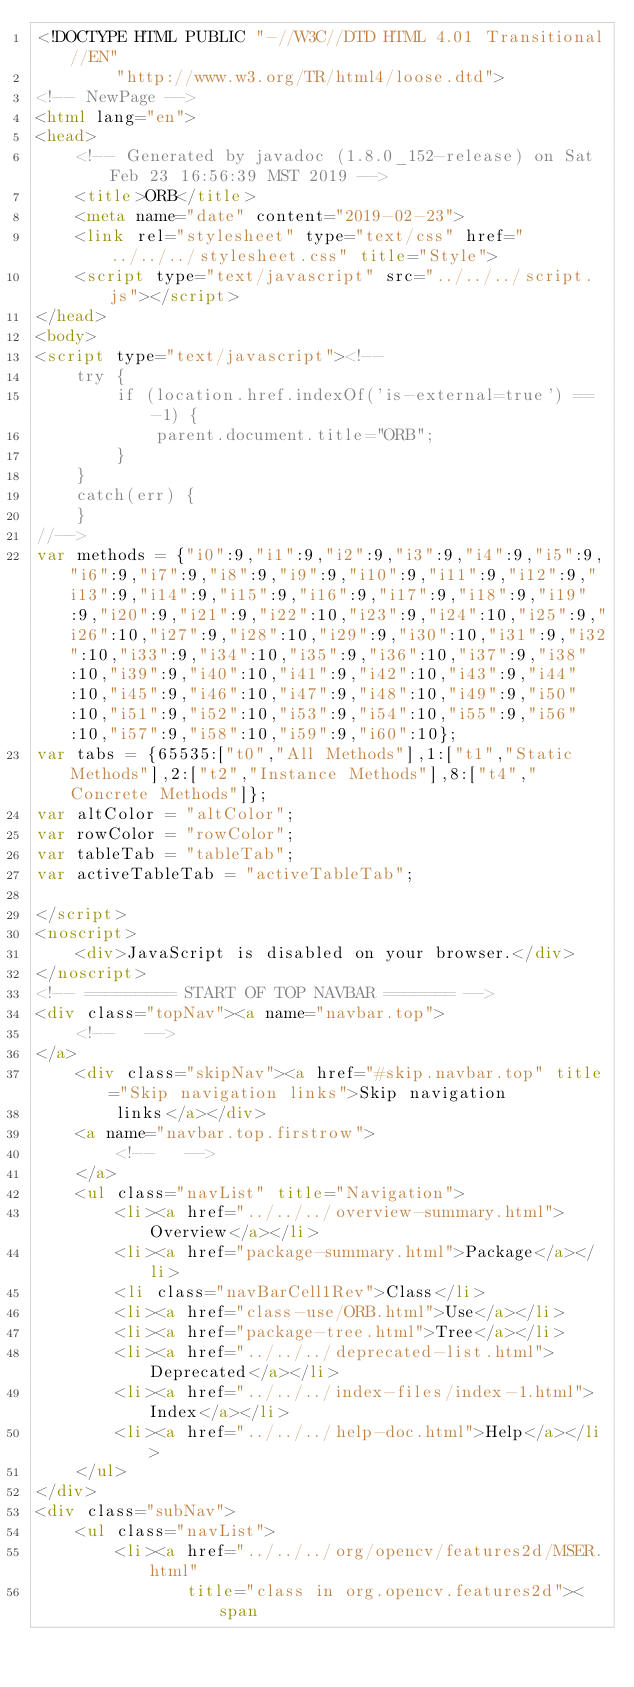Convert code to text. <code><loc_0><loc_0><loc_500><loc_500><_HTML_><!DOCTYPE HTML PUBLIC "-//W3C//DTD HTML 4.01 Transitional//EN"
        "http://www.w3.org/TR/html4/loose.dtd">
<!-- NewPage -->
<html lang="en">
<head>
    <!-- Generated by javadoc (1.8.0_152-release) on Sat Feb 23 16:56:39 MST 2019 -->
    <title>ORB</title>
    <meta name="date" content="2019-02-23">
    <link rel="stylesheet" type="text/css" href="../../../stylesheet.css" title="Style">
    <script type="text/javascript" src="../../../script.js"></script>
</head>
<body>
<script type="text/javascript"><!--
    try {
        if (location.href.indexOf('is-external=true') == -1) {
            parent.document.title="ORB";
        }
    }
    catch(err) {
    }
//-->
var methods = {"i0":9,"i1":9,"i2":9,"i3":9,"i4":9,"i5":9,"i6":9,"i7":9,"i8":9,"i9":9,"i10":9,"i11":9,"i12":9,"i13":9,"i14":9,"i15":9,"i16":9,"i17":9,"i18":9,"i19":9,"i20":9,"i21":9,"i22":10,"i23":9,"i24":10,"i25":9,"i26":10,"i27":9,"i28":10,"i29":9,"i30":10,"i31":9,"i32":10,"i33":9,"i34":10,"i35":9,"i36":10,"i37":9,"i38":10,"i39":9,"i40":10,"i41":9,"i42":10,"i43":9,"i44":10,"i45":9,"i46":10,"i47":9,"i48":10,"i49":9,"i50":10,"i51":9,"i52":10,"i53":9,"i54":10,"i55":9,"i56":10,"i57":9,"i58":10,"i59":9,"i60":10};
var tabs = {65535:["t0","All Methods"],1:["t1","Static Methods"],2:["t2","Instance Methods"],8:["t4","Concrete Methods"]};
var altColor = "altColor";
var rowColor = "rowColor";
var tableTab = "tableTab";
var activeTableTab = "activeTableTab";

</script>
<noscript>
    <div>JavaScript is disabled on your browser.</div>
</noscript>
<!-- ========= START OF TOP NAVBAR ======= -->
<div class="topNav"><a name="navbar.top">
    <!--   -->
</a>
    <div class="skipNav"><a href="#skip.navbar.top" title="Skip navigation links">Skip navigation
        links</a></div>
    <a name="navbar.top.firstrow">
        <!--   -->
    </a>
    <ul class="navList" title="Navigation">
        <li><a href="../../../overview-summary.html">Overview</a></li>
        <li><a href="package-summary.html">Package</a></li>
        <li class="navBarCell1Rev">Class</li>
        <li><a href="class-use/ORB.html">Use</a></li>
        <li><a href="package-tree.html">Tree</a></li>
        <li><a href="../../../deprecated-list.html">Deprecated</a></li>
        <li><a href="../../../index-files/index-1.html">Index</a></li>
        <li><a href="../../../help-doc.html">Help</a></li>
    </ul>
</div>
<div class="subNav">
    <ul class="navList">
        <li><a href="../../../org/opencv/features2d/MSER.html"
               title="class in org.opencv.features2d"><span</code> 